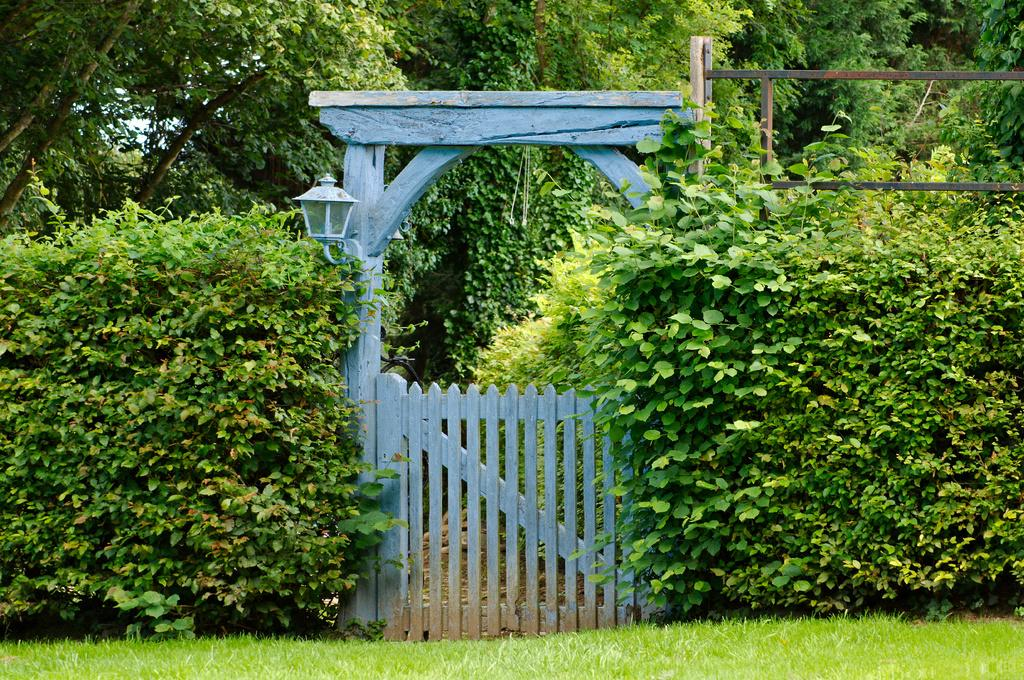What type of structure is in the image? There is a wooden gate in the image. What is attached to the wooden gate? There is an arch attached to the gate. What type of vegetation can be seen around the gate? Trees, plants, and grass are visible around the gate. What time of day is it in the image, and how does the pain affect the skate? The provided facts do not mention any time of day or any pain or skate in the image. The image only shows a wooden gate with an arch and the surrounding vegetation. 